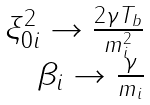<formula> <loc_0><loc_0><loc_500><loc_500>\begin{array} { r } \xi _ { 0 i } ^ { 2 } \rightarrow \frac { 2 \gamma T _ { b } } { m _ { i } ^ { 2 } } \\ \beta _ { i } \rightarrow \frac { \gamma } { m _ { i } } \end{array}</formula> 